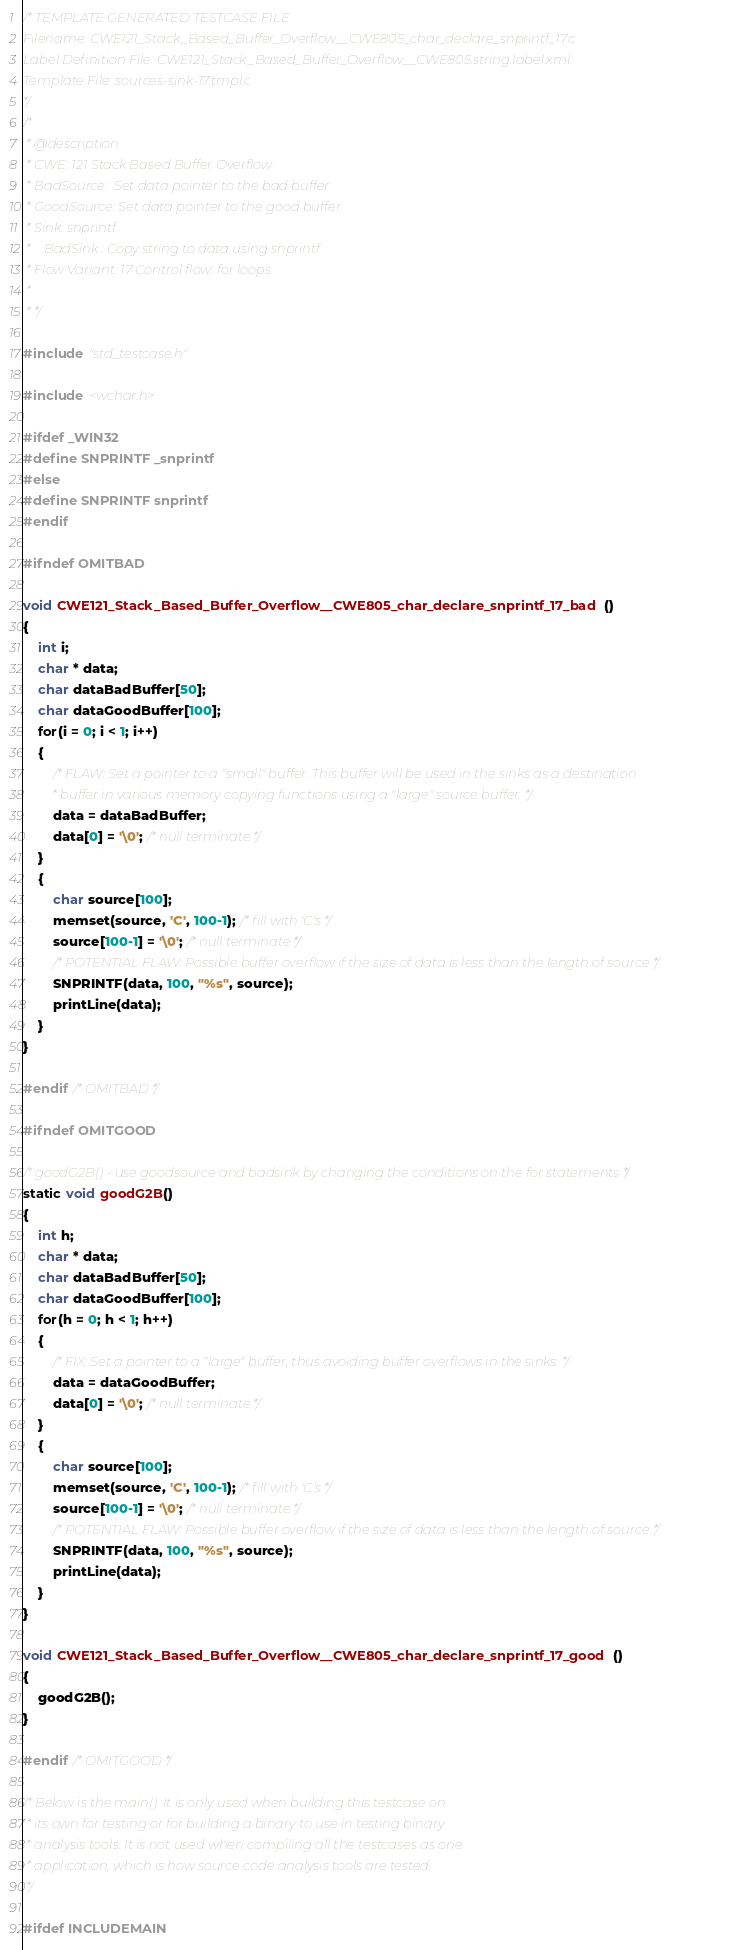Convert code to text. <code><loc_0><loc_0><loc_500><loc_500><_C_>/* TEMPLATE GENERATED TESTCASE FILE
Filename: CWE121_Stack_Based_Buffer_Overflow__CWE805_char_declare_snprintf_17.c
Label Definition File: CWE121_Stack_Based_Buffer_Overflow__CWE805.string.label.xml
Template File: sources-sink-17.tmpl.c
*/
/*
 * @description
 * CWE: 121 Stack Based Buffer Overflow
 * BadSource:  Set data pointer to the bad buffer
 * GoodSource: Set data pointer to the good buffer
 * Sink: snprintf
 *    BadSink : Copy string to data using snprintf
 * Flow Variant: 17 Control flow: for loops
 *
 * */

#include "std_testcase.h"

#include <wchar.h>

#ifdef _WIN32
#define SNPRINTF _snprintf
#else
#define SNPRINTF snprintf
#endif

#ifndef OMITBAD

void CWE121_Stack_Based_Buffer_Overflow__CWE805_char_declare_snprintf_17_bad()
{
    int i;
    char * data;
    char dataBadBuffer[50];
    char dataGoodBuffer[100];
    for(i = 0; i < 1; i++)
    {
        /* FLAW: Set a pointer to a "small" buffer. This buffer will be used in the sinks as a destination
         * buffer in various memory copying functions using a "large" source buffer. */
        data = dataBadBuffer;
        data[0] = '\0'; /* null terminate */
    }
    {
        char source[100];
        memset(source, 'C', 100-1); /* fill with 'C's */
        source[100-1] = '\0'; /* null terminate */
        /* POTENTIAL FLAW: Possible buffer overflow if the size of data is less than the length of source */
        SNPRINTF(data, 100, "%s", source);
        printLine(data);
    }
}

#endif /* OMITBAD */

#ifndef OMITGOOD

/* goodG2B() - use goodsource and badsink by changing the conditions on the for statements */
static void goodG2B()
{
    int h;
    char * data;
    char dataBadBuffer[50];
    char dataGoodBuffer[100];
    for(h = 0; h < 1; h++)
    {
        /* FIX: Set a pointer to a "large" buffer, thus avoiding buffer overflows in the sinks. */
        data = dataGoodBuffer;
        data[0] = '\0'; /* null terminate */
    }
    {
        char source[100];
        memset(source, 'C', 100-1); /* fill with 'C's */
        source[100-1] = '\0'; /* null terminate */
        /* POTENTIAL FLAW: Possible buffer overflow if the size of data is less than the length of source */
        SNPRINTF(data, 100, "%s", source);
        printLine(data);
    }
}

void CWE121_Stack_Based_Buffer_Overflow__CWE805_char_declare_snprintf_17_good()
{
    goodG2B();
}

#endif /* OMITGOOD */

/* Below is the main(). It is only used when building this testcase on
 * its own for testing or for building a binary to use in testing binary
 * analysis tools. It is not used when compiling all the testcases as one
 * application, which is how source code analysis tools are tested.
 */

#ifdef INCLUDEMAIN
</code> 